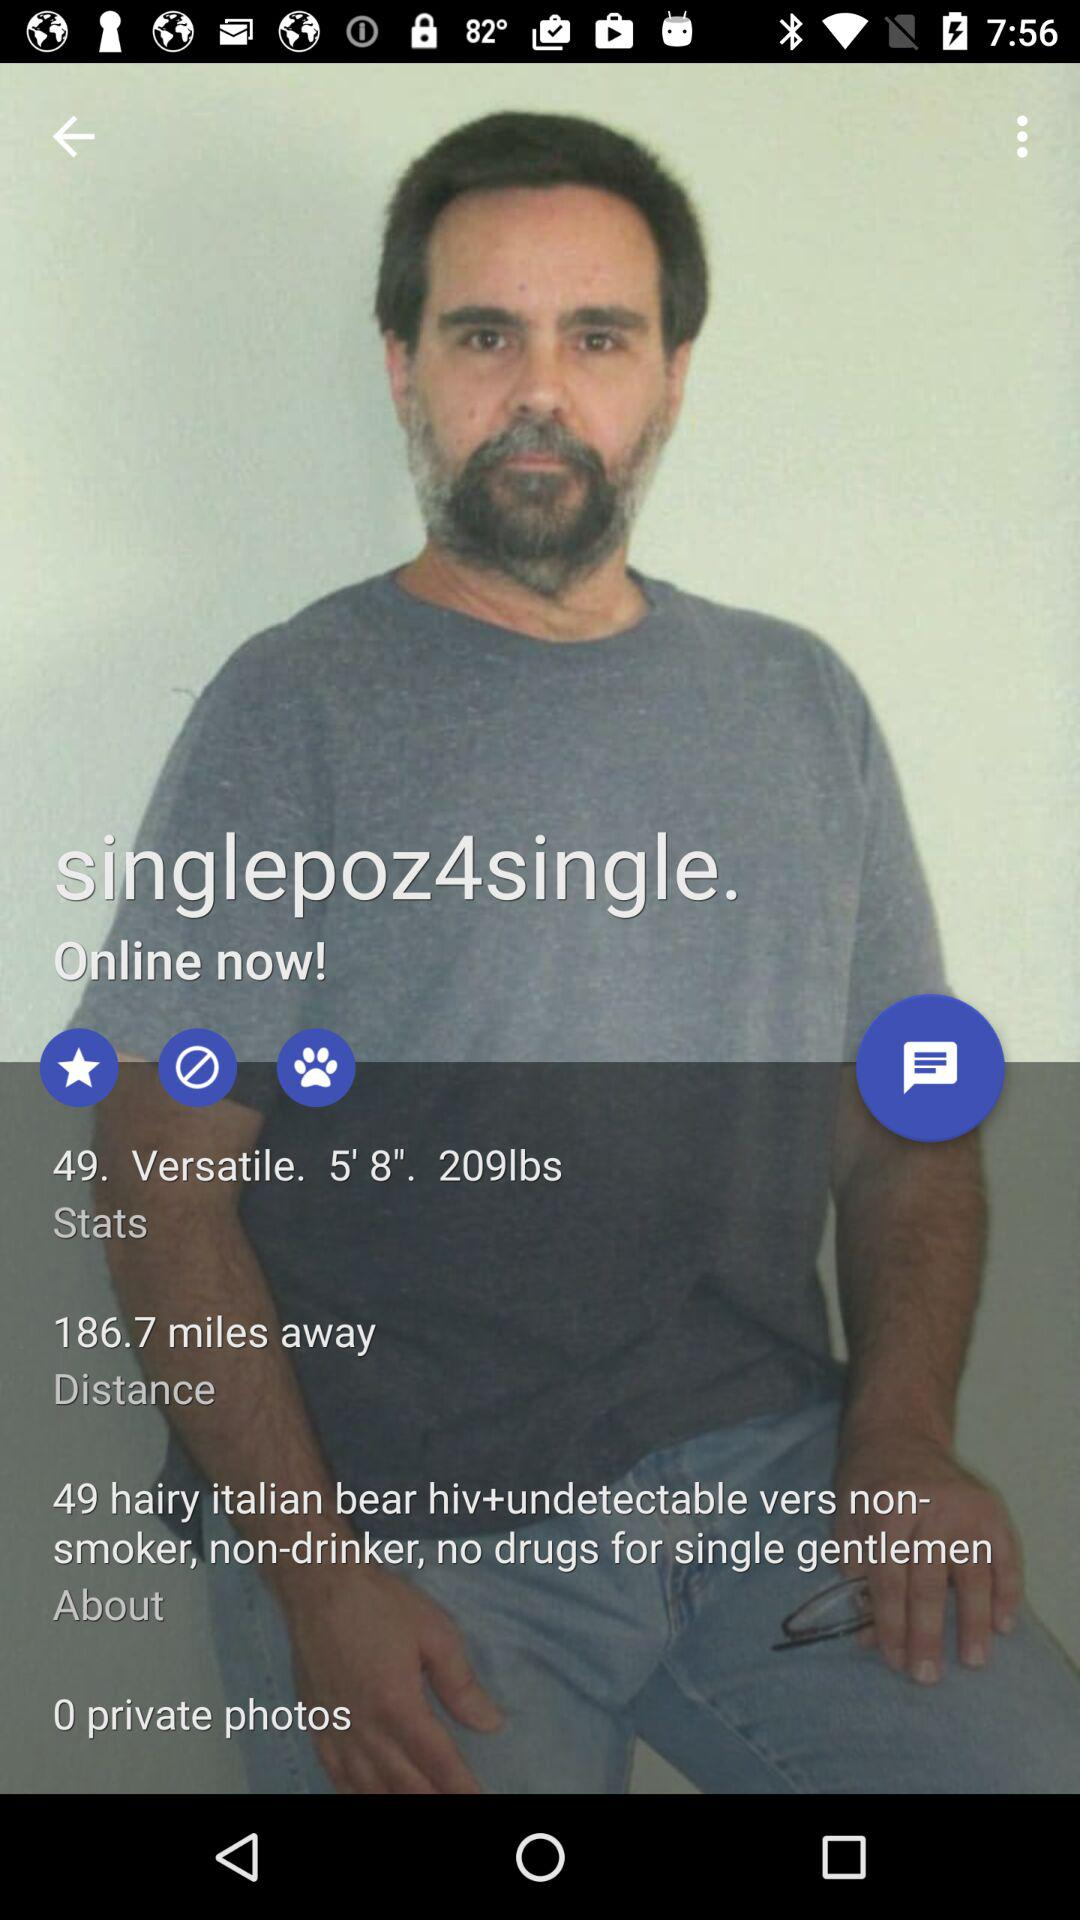What is the given distance? The given distance is 186.7 miles away. 